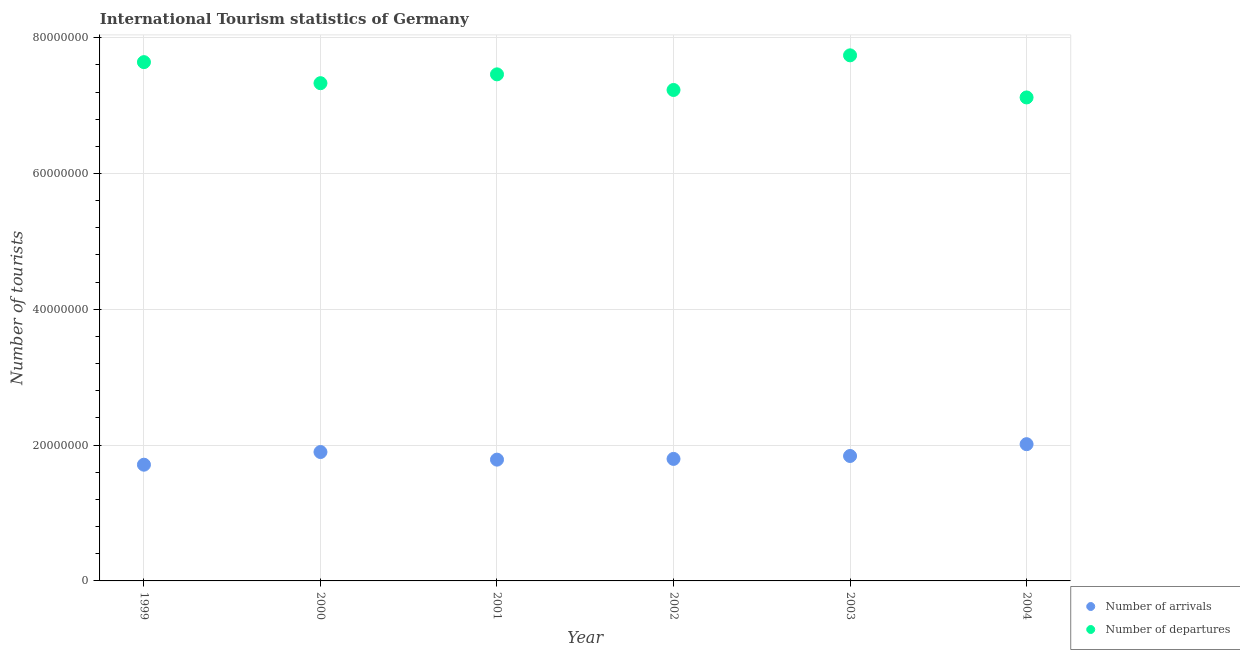How many different coloured dotlines are there?
Provide a short and direct response. 2. What is the number of tourist arrivals in 2004?
Ensure brevity in your answer.  2.01e+07. Across all years, what is the maximum number of tourist departures?
Make the answer very short. 7.74e+07. Across all years, what is the minimum number of tourist departures?
Your response must be concise. 7.12e+07. In which year was the number of tourist departures maximum?
Ensure brevity in your answer.  2003. What is the total number of tourist arrivals in the graph?
Provide a short and direct response. 1.10e+08. What is the difference between the number of tourist arrivals in 1999 and that in 2002?
Offer a very short reply. -8.53e+05. What is the difference between the number of tourist arrivals in 2001 and the number of tourist departures in 2004?
Your answer should be very brief. -5.33e+07. What is the average number of tourist departures per year?
Provide a short and direct response. 7.42e+07. In the year 2000, what is the difference between the number of tourist departures and number of tourist arrivals?
Provide a succinct answer. 5.43e+07. What is the ratio of the number of tourist arrivals in 2000 to that in 2001?
Your answer should be compact. 1.06. What is the difference between the highest and the second highest number of tourist departures?
Your response must be concise. 1.00e+06. What is the difference between the highest and the lowest number of tourist arrivals?
Make the answer very short. 3.02e+06. In how many years, is the number of tourist departures greater than the average number of tourist departures taken over all years?
Make the answer very short. 3. Is the sum of the number of tourist departures in 2000 and 2003 greater than the maximum number of tourist arrivals across all years?
Ensure brevity in your answer.  Yes. Is the number of tourist departures strictly less than the number of tourist arrivals over the years?
Provide a short and direct response. No. What is the difference between two consecutive major ticks on the Y-axis?
Offer a very short reply. 2.00e+07. Are the values on the major ticks of Y-axis written in scientific E-notation?
Keep it short and to the point. No. Does the graph contain grids?
Offer a very short reply. Yes. Where does the legend appear in the graph?
Keep it short and to the point. Bottom right. What is the title of the graph?
Your answer should be compact. International Tourism statistics of Germany. Does "Non-resident workers" appear as one of the legend labels in the graph?
Give a very brief answer. No. What is the label or title of the Y-axis?
Offer a very short reply. Number of tourists. What is the Number of tourists in Number of arrivals in 1999?
Keep it short and to the point. 1.71e+07. What is the Number of tourists in Number of departures in 1999?
Your answer should be compact. 7.64e+07. What is the Number of tourists of Number of arrivals in 2000?
Provide a succinct answer. 1.90e+07. What is the Number of tourists in Number of departures in 2000?
Make the answer very short. 7.33e+07. What is the Number of tourists of Number of arrivals in 2001?
Your response must be concise. 1.79e+07. What is the Number of tourists in Number of departures in 2001?
Offer a very short reply. 7.46e+07. What is the Number of tourists in Number of arrivals in 2002?
Offer a terse response. 1.80e+07. What is the Number of tourists in Number of departures in 2002?
Offer a terse response. 7.23e+07. What is the Number of tourists in Number of arrivals in 2003?
Make the answer very short. 1.84e+07. What is the Number of tourists in Number of departures in 2003?
Ensure brevity in your answer.  7.74e+07. What is the Number of tourists in Number of arrivals in 2004?
Offer a terse response. 2.01e+07. What is the Number of tourists in Number of departures in 2004?
Offer a terse response. 7.12e+07. Across all years, what is the maximum Number of tourists in Number of arrivals?
Your response must be concise. 2.01e+07. Across all years, what is the maximum Number of tourists of Number of departures?
Keep it short and to the point. 7.74e+07. Across all years, what is the minimum Number of tourists in Number of arrivals?
Keep it short and to the point. 1.71e+07. Across all years, what is the minimum Number of tourists of Number of departures?
Make the answer very short. 7.12e+07. What is the total Number of tourists of Number of arrivals in the graph?
Your answer should be very brief. 1.10e+08. What is the total Number of tourists in Number of departures in the graph?
Your answer should be compact. 4.45e+08. What is the difference between the Number of tourists of Number of arrivals in 1999 and that in 2000?
Provide a succinct answer. -1.87e+06. What is the difference between the Number of tourists of Number of departures in 1999 and that in 2000?
Make the answer very short. 3.10e+06. What is the difference between the Number of tourists in Number of arrivals in 1999 and that in 2001?
Keep it short and to the point. -7.45e+05. What is the difference between the Number of tourists of Number of departures in 1999 and that in 2001?
Give a very brief answer. 1.80e+06. What is the difference between the Number of tourists of Number of arrivals in 1999 and that in 2002?
Provide a succinct answer. -8.53e+05. What is the difference between the Number of tourists in Number of departures in 1999 and that in 2002?
Your answer should be compact. 4.10e+06. What is the difference between the Number of tourists of Number of arrivals in 1999 and that in 2003?
Give a very brief answer. -1.28e+06. What is the difference between the Number of tourists in Number of departures in 1999 and that in 2003?
Offer a very short reply. -1.00e+06. What is the difference between the Number of tourists in Number of arrivals in 1999 and that in 2004?
Offer a very short reply. -3.02e+06. What is the difference between the Number of tourists in Number of departures in 1999 and that in 2004?
Your response must be concise. 5.20e+06. What is the difference between the Number of tourists in Number of arrivals in 2000 and that in 2001?
Ensure brevity in your answer.  1.12e+06. What is the difference between the Number of tourists of Number of departures in 2000 and that in 2001?
Make the answer very short. -1.30e+06. What is the difference between the Number of tourists in Number of arrivals in 2000 and that in 2002?
Offer a terse response. 1.01e+06. What is the difference between the Number of tourists of Number of departures in 2000 and that in 2002?
Provide a succinct answer. 1.00e+06. What is the difference between the Number of tourists of Number of arrivals in 2000 and that in 2003?
Your answer should be very brief. 5.84e+05. What is the difference between the Number of tourists of Number of departures in 2000 and that in 2003?
Your answer should be compact. -4.10e+06. What is the difference between the Number of tourists in Number of arrivals in 2000 and that in 2004?
Your answer should be compact. -1.15e+06. What is the difference between the Number of tourists in Number of departures in 2000 and that in 2004?
Your response must be concise. 2.10e+06. What is the difference between the Number of tourists of Number of arrivals in 2001 and that in 2002?
Ensure brevity in your answer.  -1.08e+05. What is the difference between the Number of tourists of Number of departures in 2001 and that in 2002?
Your answer should be very brief. 2.30e+06. What is the difference between the Number of tourists of Number of arrivals in 2001 and that in 2003?
Give a very brief answer. -5.38e+05. What is the difference between the Number of tourists in Number of departures in 2001 and that in 2003?
Provide a succinct answer. -2.80e+06. What is the difference between the Number of tourists of Number of arrivals in 2001 and that in 2004?
Give a very brief answer. -2.28e+06. What is the difference between the Number of tourists in Number of departures in 2001 and that in 2004?
Your response must be concise. 3.40e+06. What is the difference between the Number of tourists of Number of arrivals in 2002 and that in 2003?
Your answer should be compact. -4.30e+05. What is the difference between the Number of tourists of Number of departures in 2002 and that in 2003?
Your response must be concise. -5.10e+06. What is the difference between the Number of tourists of Number of arrivals in 2002 and that in 2004?
Provide a succinct answer. -2.17e+06. What is the difference between the Number of tourists in Number of departures in 2002 and that in 2004?
Make the answer very short. 1.10e+06. What is the difference between the Number of tourists in Number of arrivals in 2003 and that in 2004?
Offer a terse response. -1.74e+06. What is the difference between the Number of tourists in Number of departures in 2003 and that in 2004?
Make the answer very short. 6.20e+06. What is the difference between the Number of tourists in Number of arrivals in 1999 and the Number of tourists in Number of departures in 2000?
Provide a short and direct response. -5.62e+07. What is the difference between the Number of tourists in Number of arrivals in 1999 and the Number of tourists in Number of departures in 2001?
Your answer should be very brief. -5.75e+07. What is the difference between the Number of tourists in Number of arrivals in 1999 and the Number of tourists in Number of departures in 2002?
Your answer should be compact. -5.52e+07. What is the difference between the Number of tourists of Number of arrivals in 1999 and the Number of tourists of Number of departures in 2003?
Your response must be concise. -6.03e+07. What is the difference between the Number of tourists of Number of arrivals in 1999 and the Number of tourists of Number of departures in 2004?
Ensure brevity in your answer.  -5.41e+07. What is the difference between the Number of tourists of Number of arrivals in 2000 and the Number of tourists of Number of departures in 2001?
Your response must be concise. -5.56e+07. What is the difference between the Number of tourists of Number of arrivals in 2000 and the Number of tourists of Number of departures in 2002?
Ensure brevity in your answer.  -5.33e+07. What is the difference between the Number of tourists of Number of arrivals in 2000 and the Number of tourists of Number of departures in 2003?
Your answer should be very brief. -5.84e+07. What is the difference between the Number of tourists of Number of arrivals in 2000 and the Number of tourists of Number of departures in 2004?
Offer a terse response. -5.22e+07. What is the difference between the Number of tourists in Number of arrivals in 2001 and the Number of tourists in Number of departures in 2002?
Your response must be concise. -5.44e+07. What is the difference between the Number of tourists of Number of arrivals in 2001 and the Number of tourists of Number of departures in 2003?
Make the answer very short. -5.95e+07. What is the difference between the Number of tourists in Number of arrivals in 2001 and the Number of tourists in Number of departures in 2004?
Your answer should be very brief. -5.33e+07. What is the difference between the Number of tourists of Number of arrivals in 2002 and the Number of tourists of Number of departures in 2003?
Keep it short and to the point. -5.94e+07. What is the difference between the Number of tourists of Number of arrivals in 2002 and the Number of tourists of Number of departures in 2004?
Your answer should be compact. -5.32e+07. What is the difference between the Number of tourists of Number of arrivals in 2003 and the Number of tourists of Number of departures in 2004?
Offer a terse response. -5.28e+07. What is the average Number of tourists in Number of arrivals per year?
Offer a very short reply. 1.84e+07. What is the average Number of tourists of Number of departures per year?
Your answer should be very brief. 7.42e+07. In the year 1999, what is the difference between the Number of tourists of Number of arrivals and Number of tourists of Number of departures?
Offer a terse response. -5.93e+07. In the year 2000, what is the difference between the Number of tourists of Number of arrivals and Number of tourists of Number of departures?
Make the answer very short. -5.43e+07. In the year 2001, what is the difference between the Number of tourists of Number of arrivals and Number of tourists of Number of departures?
Ensure brevity in your answer.  -5.67e+07. In the year 2002, what is the difference between the Number of tourists in Number of arrivals and Number of tourists in Number of departures?
Offer a very short reply. -5.43e+07. In the year 2003, what is the difference between the Number of tourists of Number of arrivals and Number of tourists of Number of departures?
Make the answer very short. -5.90e+07. In the year 2004, what is the difference between the Number of tourists in Number of arrivals and Number of tourists in Number of departures?
Offer a terse response. -5.11e+07. What is the ratio of the Number of tourists in Number of arrivals in 1999 to that in 2000?
Your answer should be compact. 0.9. What is the ratio of the Number of tourists in Number of departures in 1999 to that in 2000?
Your answer should be compact. 1.04. What is the ratio of the Number of tourists of Number of departures in 1999 to that in 2001?
Ensure brevity in your answer.  1.02. What is the ratio of the Number of tourists in Number of arrivals in 1999 to that in 2002?
Ensure brevity in your answer.  0.95. What is the ratio of the Number of tourists of Number of departures in 1999 to that in 2002?
Provide a succinct answer. 1.06. What is the ratio of the Number of tourists of Number of arrivals in 1999 to that in 2003?
Your answer should be very brief. 0.93. What is the ratio of the Number of tourists of Number of departures in 1999 to that in 2003?
Offer a terse response. 0.99. What is the ratio of the Number of tourists in Number of departures in 1999 to that in 2004?
Give a very brief answer. 1.07. What is the ratio of the Number of tourists of Number of arrivals in 2000 to that in 2001?
Offer a terse response. 1.06. What is the ratio of the Number of tourists of Number of departures in 2000 to that in 2001?
Your answer should be compact. 0.98. What is the ratio of the Number of tourists of Number of arrivals in 2000 to that in 2002?
Provide a short and direct response. 1.06. What is the ratio of the Number of tourists in Number of departures in 2000 to that in 2002?
Offer a very short reply. 1.01. What is the ratio of the Number of tourists of Number of arrivals in 2000 to that in 2003?
Give a very brief answer. 1.03. What is the ratio of the Number of tourists of Number of departures in 2000 to that in 2003?
Provide a succinct answer. 0.95. What is the ratio of the Number of tourists in Number of arrivals in 2000 to that in 2004?
Your answer should be very brief. 0.94. What is the ratio of the Number of tourists of Number of departures in 2000 to that in 2004?
Your answer should be compact. 1.03. What is the ratio of the Number of tourists of Number of arrivals in 2001 to that in 2002?
Your answer should be compact. 0.99. What is the ratio of the Number of tourists in Number of departures in 2001 to that in 2002?
Provide a succinct answer. 1.03. What is the ratio of the Number of tourists of Number of arrivals in 2001 to that in 2003?
Your response must be concise. 0.97. What is the ratio of the Number of tourists of Number of departures in 2001 to that in 2003?
Your answer should be compact. 0.96. What is the ratio of the Number of tourists in Number of arrivals in 2001 to that in 2004?
Ensure brevity in your answer.  0.89. What is the ratio of the Number of tourists of Number of departures in 2001 to that in 2004?
Offer a terse response. 1.05. What is the ratio of the Number of tourists of Number of arrivals in 2002 to that in 2003?
Your response must be concise. 0.98. What is the ratio of the Number of tourists of Number of departures in 2002 to that in 2003?
Provide a succinct answer. 0.93. What is the ratio of the Number of tourists of Number of arrivals in 2002 to that in 2004?
Offer a very short reply. 0.89. What is the ratio of the Number of tourists of Number of departures in 2002 to that in 2004?
Offer a terse response. 1.02. What is the ratio of the Number of tourists of Number of arrivals in 2003 to that in 2004?
Give a very brief answer. 0.91. What is the ratio of the Number of tourists in Number of departures in 2003 to that in 2004?
Give a very brief answer. 1.09. What is the difference between the highest and the second highest Number of tourists of Number of arrivals?
Offer a terse response. 1.15e+06. What is the difference between the highest and the lowest Number of tourists of Number of arrivals?
Give a very brief answer. 3.02e+06. What is the difference between the highest and the lowest Number of tourists of Number of departures?
Make the answer very short. 6.20e+06. 